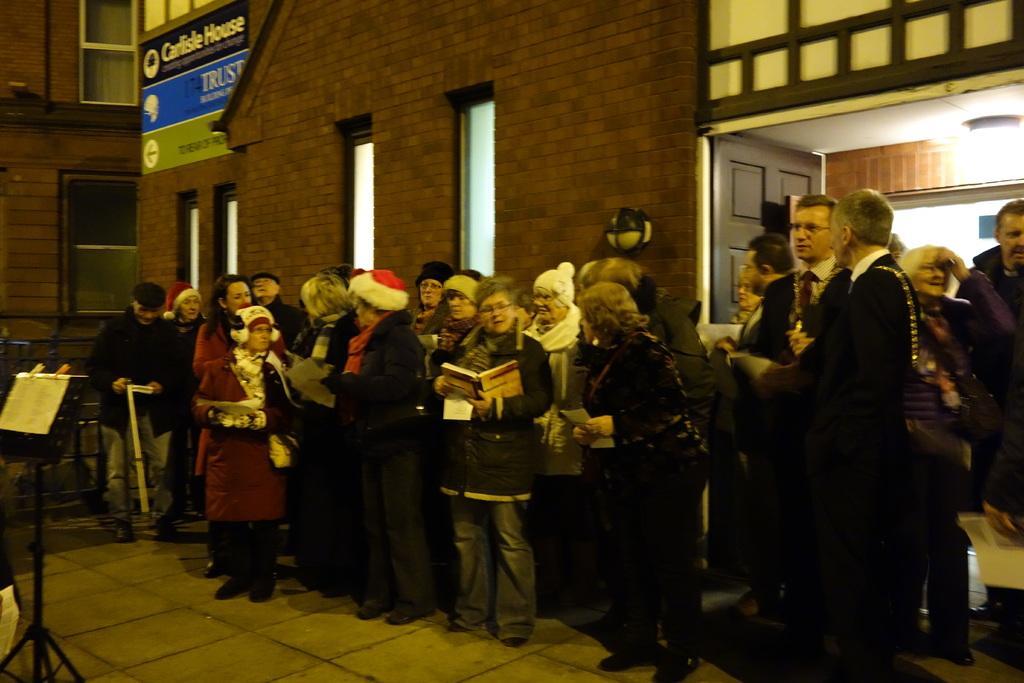In one or two sentences, can you explain what this image depicts? In this image, we can see some people standing, we can see the wall and some windows on the wall. We can see some sign boards and there is a black color stand on the left side. 